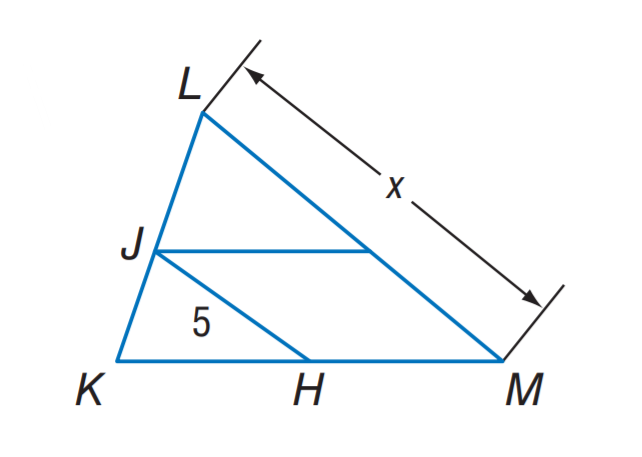Question: J H is a midsegment of \triangle K L M. Find x.
Choices:
A. 5
B. 10
C. 15
D. 20
Answer with the letter. Answer: B 